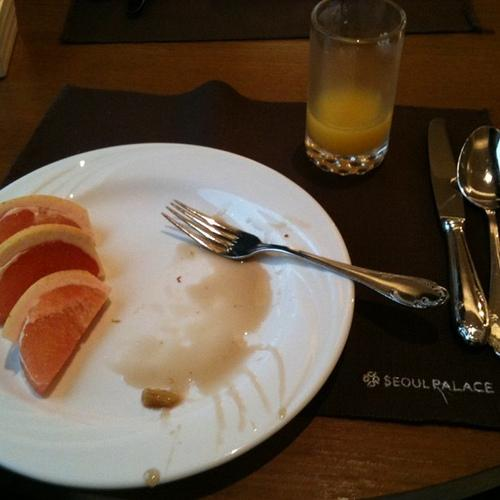Describe the interaction between the different objects on the table. The silver fork, knife, and spoon are in close proximity to the plates and the placemat, indicating they were used during the meal. The glass of orange juice is placed near the placemat, suggesting it was also consumed during the meal. How many pieces of silverware and what types are on the table? There are three pieces of silverware: a silver fork, a silver knife, and a silver spoon. Assess the image quality based on the clarity and detail provided in the object descriptions. The image quality appears to be high, as details of the silverware, plates, glass, and food are precisely described with their respective bounding box coordinates. Give a brief description of the table and the place mat's setting. The table has a light brown wooden surface, while the place mat setting consists of a black place mat displaying the name 'Seoul Palace' stitched on it, silverware atop it, and a plate with a half-eaten breakfast nearby. Analyze the image sentiment by describing the scene in terms of emotions or feelings it evokes. The image reflects a casual and relaxed atmosphere after someone has enjoyed a meal, leaving a sense of contentment and satiation. Count and describe the variety of beverages present in the image. There is one type of beverage: orange juice is in a drinking glass with a thick bottom. Identify three objects on the table and describe their appearance. A dirty white plate with remnants of syrup, silverware placed on a black placemat, and a drinking glass containing orange juice. Provide a brief description of the food on the table. There is a half-eaten breakfast, with grapefruit wedges on a white plate, along with a dirty white plate that has crumbs and syrup left from the meal. 